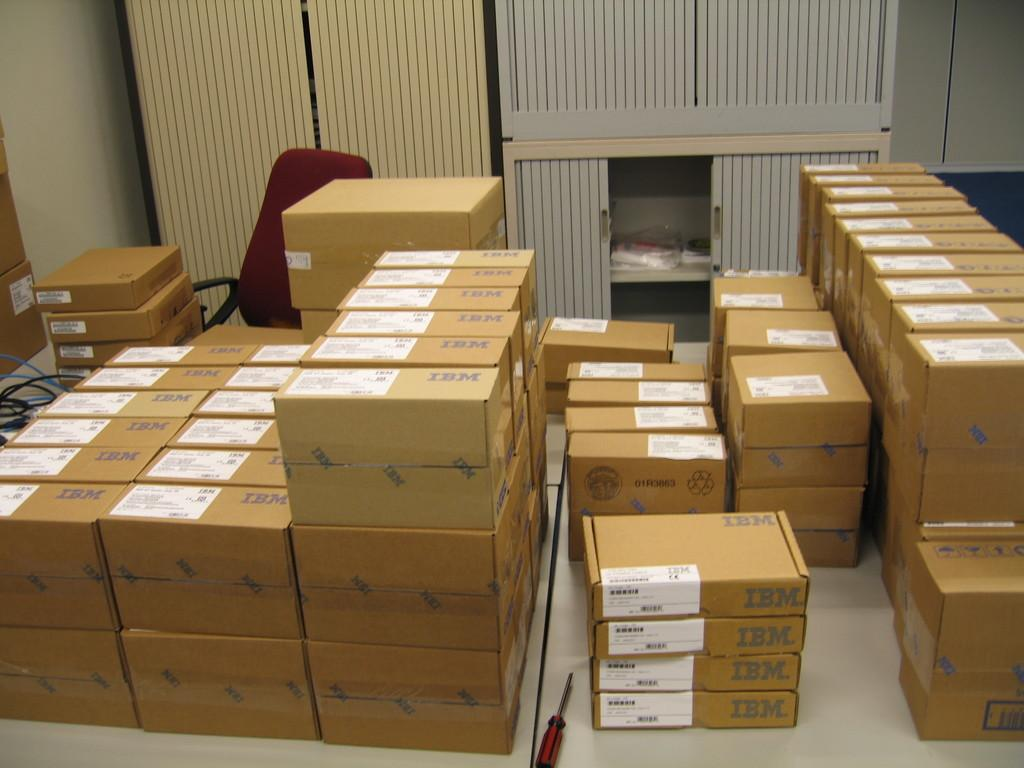<image>
Share a concise interpretation of the image provided. The IBM boxes are in stacks of boxes of matching sizes. 